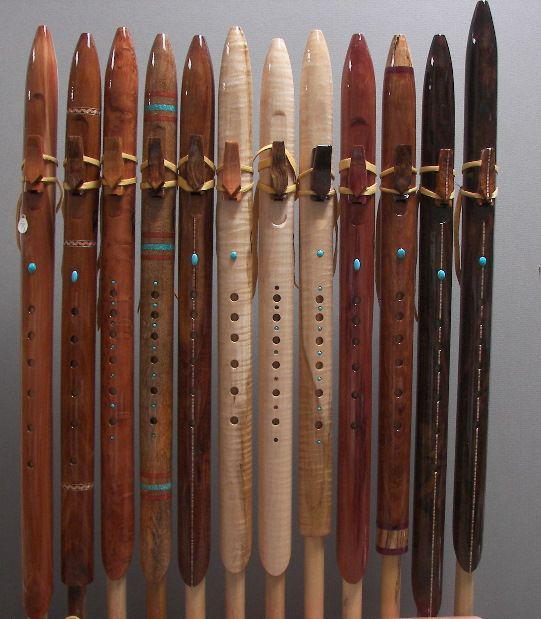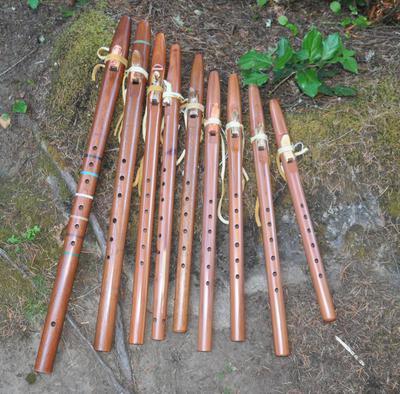The first image is the image on the left, the second image is the image on the right. Given the left and right images, does the statement "The right image shows a rustic curved wooden flute with brown straps at its top, and it is displayed end-first." hold true? Answer yes or no. No. The first image is the image on the left, the second image is the image on the right. For the images shown, is this caption "There are less than three instruments in the right image." true? Answer yes or no. No. 